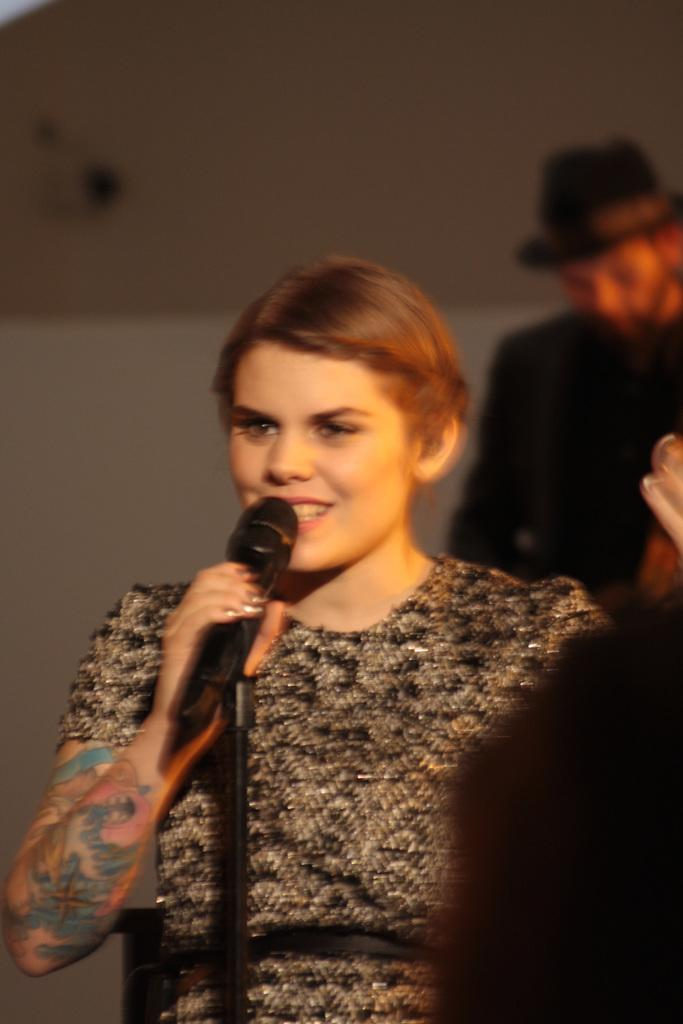Who is the main subject in the image? There is a lady in the image. What is the lady wearing? The lady is wearing a black dress. Can you describe any distinguishing features of the lady? The lady has a tattoo on her right hand and short hair. What is the lady holding in her right hand? The lady is holding a microphone in her right hand. What type of root can be seen growing on the lady's left arm in the image? There is no root growing on the lady's left arm in the image. 